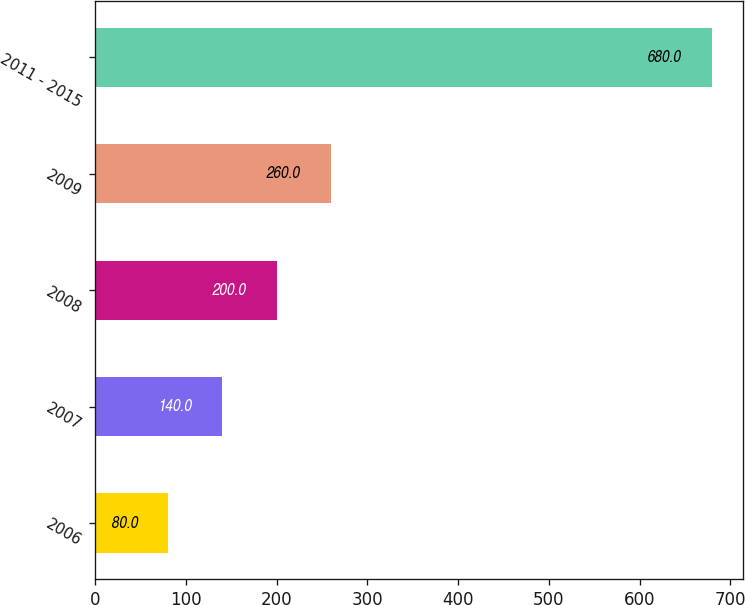Convert chart to OTSL. <chart><loc_0><loc_0><loc_500><loc_500><bar_chart><fcel>2006<fcel>2007<fcel>2008<fcel>2009<fcel>2011 - 2015<nl><fcel>80<fcel>140<fcel>200<fcel>260<fcel>680<nl></chart> 